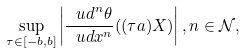<formula> <loc_0><loc_0><loc_500><loc_500>\sup _ { \tau \in [ - b , b ] } \left | \frac { { \ u d } ^ { n } \theta } { { \ u d } x ^ { n } } ( ( \tau a ) X ) \right | , n \in { \mathcal { N } } ,</formula> 